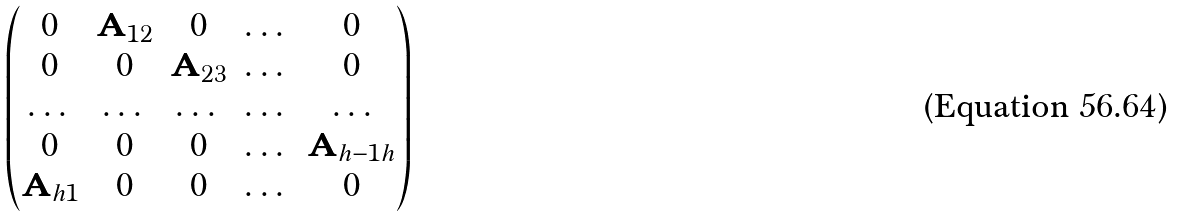Convert formula to latex. <formula><loc_0><loc_0><loc_500><loc_500>\begin{pmatrix} 0 & { \mathbf A } _ { 1 2 } & 0 & \dots & 0 \\ 0 & 0 & { \mathbf A } _ { 2 3 } & \dots & 0 \\ \dots & \dots & \dots & \dots & \dots \\ 0 & 0 & 0 & \dots & { \mathbf A } _ { h - 1 h } \\ { \mathbf A } _ { h 1 } & 0 & 0 & \dots & 0 \end{pmatrix}</formula> 